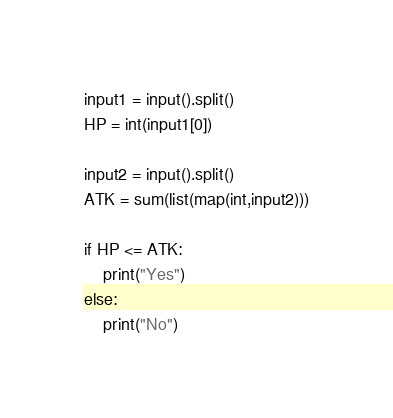<code> <loc_0><loc_0><loc_500><loc_500><_Python_>input1 = input().split()
HP = int(input1[0])

input2 = input().split()
ATK = sum(list(map(int,input2)))

if HP <= ATK:
    print("Yes")
else:
    print("No")</code> 